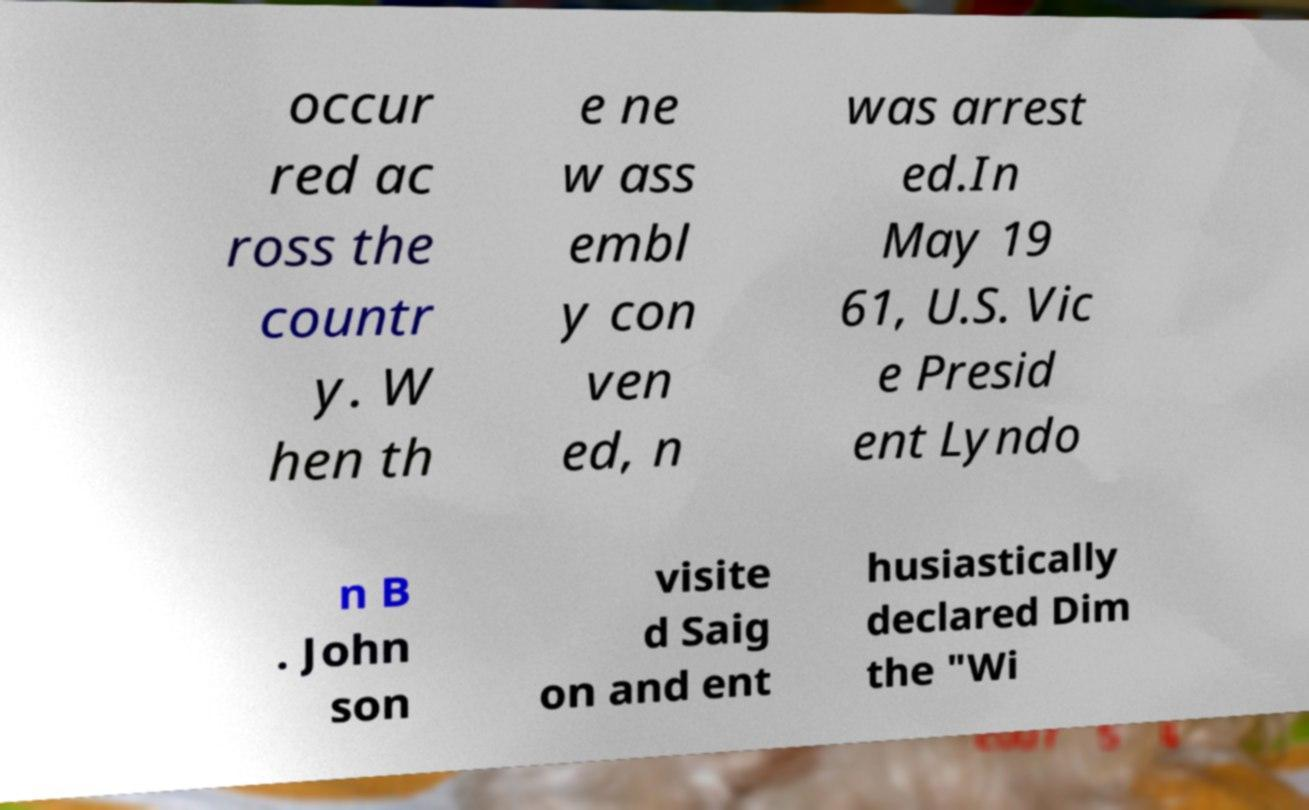Please read and relay the text visible in this image. What does it say? occur red ac ross the countr y. W hen th e ne w ass embl y con ven ed, n was arrest ed.In May 19 61, U.S. Vic e Presid ent Lyndo n B . John son visite d Saig on and ent husiastically declared Dim the "Wi 